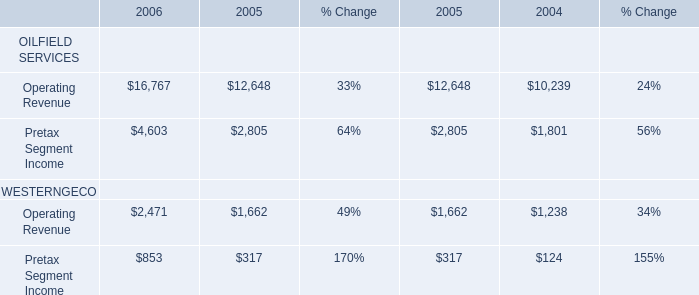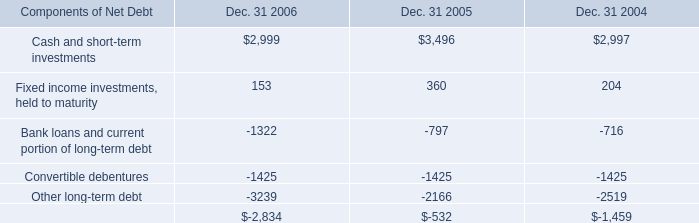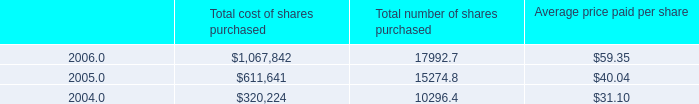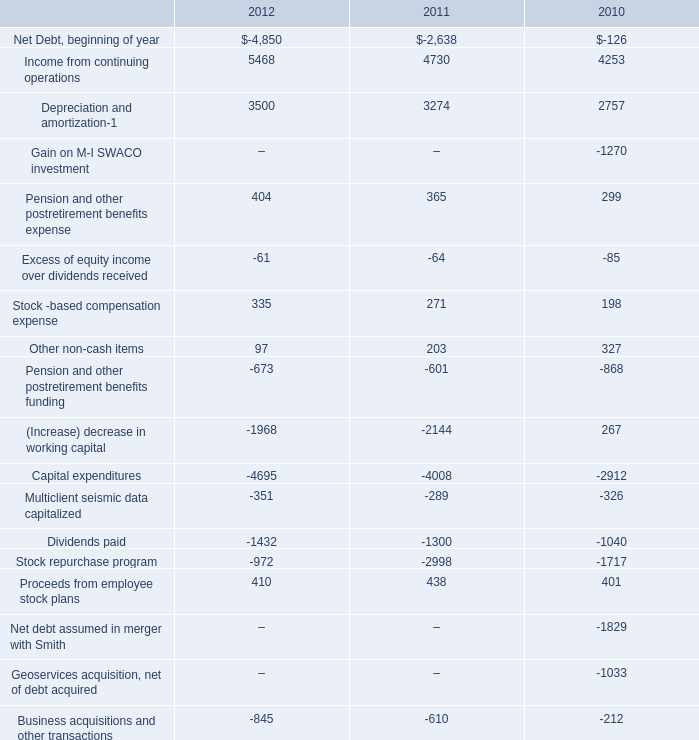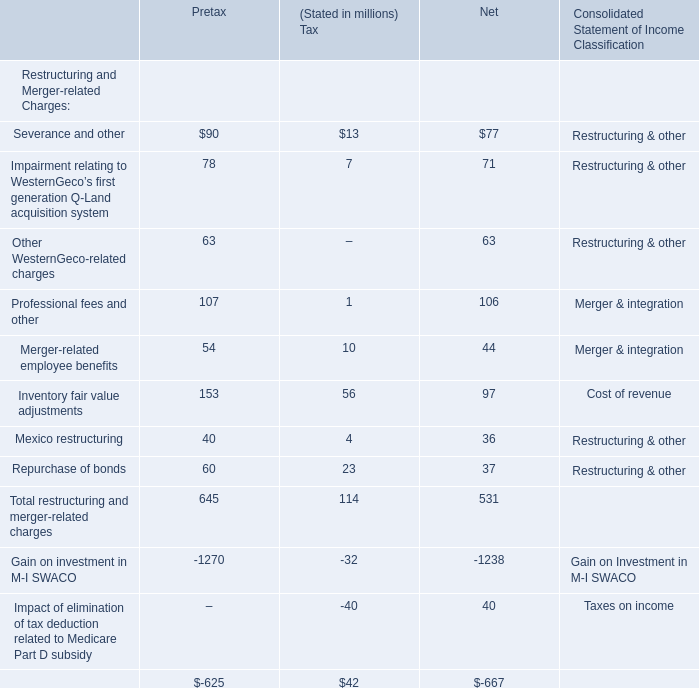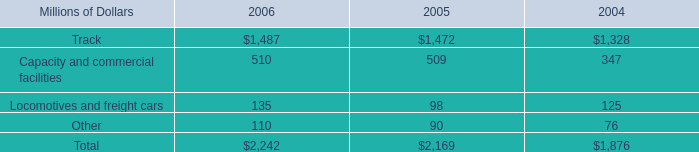What was the average of the Dividends paid in the years where Translation effect on net debt is positive? 
Computations: ((-1300 - 1040) / 2)
Answer: -1170.0. 